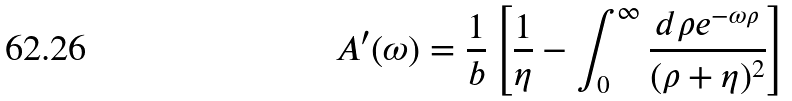<formula> <loc_0><loc_0><loc_500><loc_500>A ^ { \prime } ( \omega ) = \frac { 1 } { b } \left [ \frac { 1 } { \eta } - \int _ { 0 } ^ { \infty } \frac { d \rho e ^ { - \omega \rho } } { ( \rho + \eta ) ^ { 2 } } \right ]</formula> 